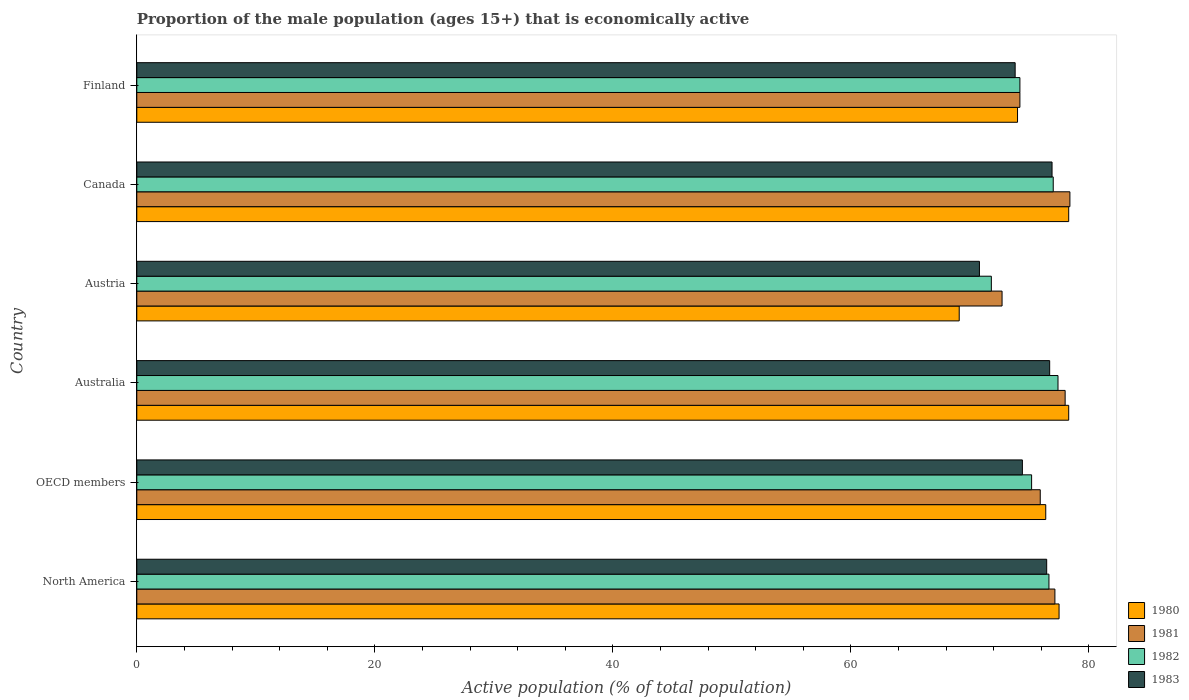How many different coloured bars are there?
Give a very brief answer. 4. How many groups of bars are there?
Provide a short and direct response. 6. Are the number of bars on each tick of the Y-axis equal?
Your response must be concise. Yes. How many bars are there on the 4th tick from the top?
Make the answer very short. 4. How many bars are there on the 5th tick from the bottom?
Your response must be concise. 4. What is the label of the 1st group of bars from the top?
Offer a terse response. Finland. What is the proportion of the male population that is economically active in 1982 in Finland?
Your answer should be compact. 74.2. Across all countries, what is the maximum proportion of the male population that is economically active in 1980?
Give a very brief answer. 78.3. Across all countries, what is the minimum proportion of the male population that is economically active in 1981?
Keep it short and to the point. 72.7. In which country was the proportion of the male population that is economically active in 1980 maximum?
Offer a very short reply. Australia. What is the total proportion of the male population that is economically active in 1983 in the graph?
Your answer should be very brief. 449.06. What is the difference between the proportion of the male population that is economically active in 1982 in Australia and that in Austria?
Provide a succinct answer. 5.6. What is the difference between the proportion of the male population that is economically active in 1980 in OECD members and the proportion of the male population that is economically active in 1982 in Canada?
Offer a terse response. -0.63. What is the average proportion of the male population that is economically active in 1980 per country?
Your response must be concise. 75.59. What is the difference between the proportion of the male population that is economically active in 1981 and proportion of the male population that is economically active in 1983 in Austria?
Keep it short and to the point. 1.9. In how many countries, is the proportion of the male population that is economically active in 1981 greater than 68 %?
Ensure brevity in your answer.  6. What is the ratio of the proportion of the male population that is economically active in 1983 in Canada to that in OECD members?
Make the answer very short. 1.03. Is the difference between the proportion of the male population that is economically active in 1981 in Austria and OECD members greater than the difference between the proportion of the male population that is economically active in 1983 in Austria and OECD members?
Give a very brief answer. Yes. What is the difference between the highest and the second highest proportion of the male population that is economically active in 1981?
Provide a short and direct response. 0.4. What is the difference between the highest and the lowest proportion of the male population that is economically active in 1980?
Ensure brevity in your answer.  9.2. In how many countries, is the proportion of the male population that is economically active in 1980 greater than the average proportion of the male population that is economically active in 1980 taken over all countries?
Make the answer very short. 4. Is the sum of the proportion of the male population that is economically active in 1981 in Canada and OECD members greater than the maximum proportion of the male population that is economically active in 1982 across all countries?
Provide a succinct answer. Yes. What does the 2nd bar from the bottom in Finland represents?
Keep it short and to the point. 1981. How many bars are there?
Your response must be concise. 24. How many countries are there in the graph?
Give a very brief answer. 6. Does the graph contain any zero values?
Offer a terse response. No. Does the graph contain grids?
Your response must be concise. No. How are the legend labels stacked?
Offer a very short reply. Vertical. What is the title of the graph?
Give a very brief answer. Proportion of the male population (ages 15+) that is economically active. What is the label or title of the X-axis?
Offer a very short reply. Active population (% of total population). What is the Active population (% of total population) in 1980 in North America?
Offer a terse response. 77.49. What is the Active population (% of total population) in 1981 in North America?
Your answer should be compact. 77.14. What is the Active population (% of total population) in 1982 in North America?
Your answer should be very brief. 76.64. What is the Active population (% of total population) in 1983 in North America?
Make the answer very short. 76.45. What is the Active population (% of total population) in 1980 in OECD members?
Your answer should be very brief. 76.37. What is the Active population (% of total population) in 1981 in OECD members?
Give a very brief answer. 75.91. What is the Active population (% of total population) in 1982 in OECD members?
Offer a very short reply. 75.18. What is the Active population (% of total population) in 1983 in OECD members?
Provide a short and direct response. 74.41. What is the Active population (% of total population) in 1980 in Australia?
Give a very brief answer. 78.3. What is the Active population (% of total population) of 1982 in Australia?
Your response must be concise. 77.4. What is the Active population (% of total population) of 1983 in Australia?
Keep it short and to the point. 76.7. What is the Active population (% of total population) in 1980 in Austria?
Offer a very short reply. 69.1. What is the Active population (% of total population) of 1981 in Austria?
Your answer should be very brief. 72.7. What is the Active population (% of total population) in 1982 in Austria?
Provide a short and direct response. 71.8. What is the Active population (% of total population) of 1983 in Austria?
Offer a very short reply. 70.8. What is the Active population (% of total population) in 1980 in Canada?
Give a very brief answer. 78.3. What is the Active population (% of total population) of 1981 in Canada?
Your response must be concise. 78.4. What is the Active population (% of total population) in 1982 in Canada?
Your answer should be compact. 77. What is the Active population (% of total population) in 1983 in Canada?
Provide a short and direct response. 76.9. What is the Active population (% of total population) in 1981 in Finland?
Your response must be concise. 74.2. What is the Active population (% of total population) in 1982 in Finland?
Your response must be concise. 74.2. What is the Active population (% of total population) in 1983 in Finland?
Make the answer very short. 73.8. Across all countries, what is the maximum Active population (% of total population) of 1980?
Offer a terse response. 78.3. Across all countries, what is the maximum Active population (% of total population) in 1981?
Your answer should be compact. 78.4. Across all countries, what is the maximum Active population (% of total population) of 1982?
Ensure brevity in your answer.  77.4. Across all countries, what is the maximum Active population (% of total population) in 1983?
Provide a succinct answer. 76.9. Across all countries, what is the minimum Active population (% of total population) in 1980?
Offer a very short reply. 69.1. Across all countries, what is the minimum Active population (% of total population) of 1981?
Offer a terse response. 72.7. Across all countries, what is the minimum Active population (% of total population) in 1982?
Keep it short and to the point. 71.8. Across all countries, what is the minimum Active population (% of total population) in 1983?
Ensure brevity in your answer.  70.8. What is the total Active population (% of total population) of 1980 in the graph?
Give a very brief answer. 453.56. What is the total Active population (% of total population) in 1981 in the graph?
Give a very brief answer. 456.35. What is the total Active population (% of total population) in 1982 in the graph?
Make the answer very short. 452.22. What is the total Active population (% of total population) in 1983 in the graph?
Your answer should be very brief. 449.06. What is the difference between the Active population (% of total population) of 1980 in North America and that in OECD members?
Provide a succinct answer. 1.12. What is the difference between the Active population (% of total population) of 1981 in North America and that in OECD members?
Provide a succinct answer. 1.23. What is the difference between the Active population (% of total population) in 1982 in North America and that in OECD members?
Keep it short and to the point. 1.46. What is the difference between the Active population (% of total population) of 1983 in North America and that in OECD members?
Offer a very short reply. 2.04. What is the difference between the Active population (% of total population) of 1980 in North America and that in Australia?
Provide a succinct answer. -0.81. What is the difference between the Active population (% of total population) of 1981 in North America and that in Australia?
Provide a short and direct response. -0.86. What is the difference between the Active population (% of total population) of 1982 in North America and that in Australia?
Make the answer very short. -0.76. What is the difference between the Active population (% of total population) of 1983 in North America and that in Australia?
Offer a very short reply. -0.25. What is the difference between the Active population (% of total population) of 1980 in North America and that in Austria?
Your answer should be very brief. 8.39. What is the difference between the Active population (% of total population) of 1981 in North America and that in Austria?
Keep it short and to the point. 4.44. What is the difference between the Active population (% of total population) of 1982 in North America and that in Austria?
Give a very brief answer. 4.84. What is the difference between the Active population (% of total population) of 1983 in North America and that in Austria?
Keep it short and to the point. 5.65. What is the difference between the Active population (% of total population) in 1980 in North America and that in Canada?
Your answer should be very brief. -0.81. What is the difference between the Active population (% of total population) of 1981 in North America and that in Canada?
Make the answer very short. -1.26. What is the difference between the Active population (% of total population) in 1982 in North America and that in Canada?
Your answer should be very brief. -0.36. What is the difference between the Active population (% of total population) of 1983 in North America and that in Canada?
Offer a terse response. -0.45. What is the difference between the Active population (% of total population) in 1980 in North America and that in Finland?
Ensure brevity in your answer.  3.49. What is the difference between the Active population (% of total population) of 1981 in North America and that in Finland?
Offer a terse response. 2.94. What is the difference between the Active population (% of total population) in 1982 in North America and that in Finland?
Keep it short and to the point. 2.44. What is the difference between the Active population (% of total population) in 1983 in North America and that in Finland?
Offer a terse response. 2.65. What is the difference between the Active population (% of total population) in 1980 in OECD members and that in Australia?
Give a very brief answer. -1.93. What is the difference between the Active population (% of total population) of 1981 in OECD members and that in Australia?
Give a very brief answer. -2.09. What is the difference between the Active population (% of total population) in 1982 in OECD members and that in Australia?
Your response must be concise. -2.22. What is the difference between the Active population (% of total population) in 1983 in OECD members and that in Australia?
Your answer should be very brief. -2.29. What is the difference between the Active population (% of total population) of 1980 in OECD members and that in Austria?
Your answer should be compact. 7.27. What is the difference between the Active population (% of total population) in 1981 in OECD members and that in Austria?
Offer a very short reply. 3.21. What is the difference between the Active population (% of total population) of 1982 in OECD members and that in Austria?
Your answer should be very brief. 3.38. What is the difference between the Active population (% of total population) in 1983 in OECD members and that in Austria?
Offer a very short reply. 3.61. What is the difference between the Active population (% of total population) in 1980 in OECD members and that in Canada?
Keep it short and to the point. -1.93. What is the difference between the Active population (% of total population) of 1981 in OECD members and that in Canada?
Keep it short and to the point. -2.49. What is the difference between the Active population (% of total population) of 1982 in OECD members and that in Canada?
Your answer should be very brief. -1.82. What is the difference between the Active population (% of total population) of 1983 in OECD members and that in Canada?
Your answer should be very brief. -2.49. What is the difference between the Active population (% of total population) in 1980 in OECD members and that in Finland?
Your response must be concise. 2.37. What is the difference between the Active population (% of total population) in 1981 in OECD members and that in Finland?
Your response must be concise. 1.71. What is the difference between the Active population (% of total population) in 1982 in OECD members and that in Finland?
Offer a very short reply. 0.98. What is the difference between the Active population (% of total population) in 1983 in OECD members and that in Finland?
Ensure brevity in your answer.  0.61. What is the difference between the Active population (% of total population) in 1982 in Australia and that in Austria?
Make the answer very short. 5.6. What is the difference between the Active population (% of total population) of 1983 in Australia and that in Austria?
Your answer should be compact. 5.9. What is the difference between the Active population (% of total population) in 1980 in Australia and that in Finland?
Offer a very short reply. 4.3. What is the difference between the Active population (% of total population) in 1982 in Australia and that in Finland?
Ensure brevity in your answer.  3.2. What is the difference between the Active population (% of total population) of 1981 in Austria and that in Canada?
Provide a short and direct response. -5.7. What is the difference between the Active population (% of total population) in 1981 in Austria and that in Finland?
Keep it short and to the point. -1.5. What is the difference between the Active population (% of total population) in 1982 in Austria and that in Finland?
Your response must be concise. -2.4. What is the difference between the Active population (% of total population) of 1983 in Austria and that in Finland?
Your response must be concise. -3. What is the difference between the Active population (% of total population) in 1980 in North America and the Active population (% of total population) in 1981 in OECD members?
Your answer should be compact. 1.58. What is the difference between the Active population (% of total population) of 1980 in North America and the Active population (% of total population) of 1982 in OECD members?
Your answer should be compact. 2.31. What is the difference between the Active population (% of total population) of 1980 in North America and the Active population (% of total population) of 1983 in OECD members?
Your response must be concise. 3.08. What is the difference between the Active population (% of total population) in 1981 in North America and the Active population (% of total population) in 1982 in OECD members?
Offer a very short reply. 1.96. What is the difference between the Active population (% of total population) in 1981 in North America and the Active population (% of total population) in 1983 in OECD members?
Offer a very short reply. 2.73. What is the difference between the Active population (% of total population) of 1982 in North America and the Active population (% of total population) of 1983 in OECD members?
Your response must be concise. 2.23. What is the difference between the Active population (% of total population) of 1980 in North America and the Active population (% of total population) of 1981 in Australia?
Provide a short and direct response. -0.51. What is the difference between the Active population (% of total population) of 1980 in North America and the Active population (% of total population) of 1982 in Australia?
Ensure brevity in your answer.  0.09. What is the difference between the Active population (% of total population) in 1980 in North America and the Active population (% of total population) in 1983 in Australia?
Your answer should be very brief. 0.79. What is the difference between the Active population (% of total population) of 1981 in North America and the Active population (% of total population) of 1982 in Australia?
Offer a very short reply. -0.26. What is the difference between the Active population (% of total population) of 1981 in North America and the Active population (% of total population) of 1983 in Australia?
Offer a terse response. 0.44. What is the difference between the Active population (% of total population) of 1982 in North America and the Active population (% of total population) of 1983 in Australia?
Ensure brevity in your answer.  -0.06. What is the difference between the Active population (% of total population) in 1980 in North America and the Active population (% of total population) in 1981 in Austria?
Offer a very short reply. 4.79. What is the difference between the Active population (% of total population) of 1980 in North America and the Active population (% of total population) of 1982 in Austria?
Provide a short and direct response. 5.69. What is the difference between the Active population (% of total population) of 1980 in North America and the Active population (% of total population) of 1983 in Austria?
Give a very brief answer. 6.69. What is the difference between the Active population (% of total population) in 1981 in North America and the Active population (% of total population) in 1982 in Austria?
Provide a short and direct response. 5.34. What is the difference between the Active population (% of total population) of 1981 in North America and the Active population (% of total population) of 1983 in Austria?
Give a very brief answer. 6.34. What is the difference between the Active population (% of total population) of 1982 in North America and the Active population (% of total population) of 1983 in Austria?
Offer a very short reply. 5.84. What is the difference between the Active population (% of total population) of 1980 in North America and the Active population (% of total population) of 1981 in Canada?
Give a very brief answer. -0.91. What is the difference between the Active population (% of total population) in 1980 in North America and the Active population (% of total population) in 1982 in Canada?
Your answer should be compact. 0.49. What is the difference between the Active population (% of total population) of 1980 in North America and the Active population (% of total population) of 1983 in Canada?
Ensure brevity in your answer.  0.59. What is the difference between the Active population (% of total population) of 1981 in North America and the Active population (% of total population) of 1982 in Canada?
Your response must be concise. 0.14. What is the difference between the Active population (% of total population) in 1981 in North America and the Active population (% of total population) in 1983 in Canada?
Give a very brief answer. 0.24. What is the difference between the Active population (% of total population) in 1982 in North America and the Active population (% of total population) in 1983 in Canada?
Offer a terse response. -0.26. What is the difference between the Active population (% of total population) in 1980 in North America and the Active population (% of total population) in 1981 in Finland?
Offer a very short reply. 3.29. What is the difference between the Active population (% of total population) in 1980 in North America and the Active population (% of total population) in 1982 in Finland?
Your answer should be very brief. 3.29. What is the difference between the Active population (% of total population) of 1980 in North America and the Active population (% of total population) of 1983 in Finland?
Provide a short and direct response. 3.69. What is the difference between the Active population (% of total population) in 1981 in North America and the Active population (% of total population) in 1982 in Finland?
Your answer should be very brief. 2.94. What is the difference between the Active population (% of total population) of 1981 in North America and the Active population (% of total population) of 1983 in Finland?
Make the answer very short. 3.34. What is the difference between the Active population (% of total population) in 1982 in North America and the Active population (% of total population) in 1983 in Finland?
Your response must be concise. 2.84. What is the difference between the Active population (% of total population) in 1980 in OECD members and the Active population (% of total population) in 1981 in Australia?
Your response must be concise. -1.63. What is the difference between the Active population (% of total population) of 1980 in OECD members and the Active population (% of total population) of 1982 in Australia?
Your answer should be compact. -1.03. What is the difference between the Active population (% of total population) of 1980 in OECD members and the Active population (% of total population) of 1983 in Australia?
Ensure brevity in your answer.  -0.33. What is the difference between the Active population (% of total population) of 1981 in OECD members and the Active population (% of total population) of 1982 in Australia?
Provide a succinct answer. -1.49. What is the difference between the Active population (% of total population) of 1981 in OECD members and the Active population (% of total population) of 1983 in Australia?
Your answer should be compact. -0.79. What is the difference between the Active population (% of total population) of 1982 in OECD members and the Active population (% of total population) of 1983 in Australia?
Your answer should be very brief. -1.52. What is the difference between the Active population (% of total population) of 1980 in OECD members and the Active population (% of total population) of 1981 in Austria?
Ensure brevity in your answer.  3.67. What is the difference between the Active population (% of total population) of 1980 in OECD members and the Active population (% of total population) of 1982 in Austria?
Keep it short and to the point. 4.57. What is the difference between the Active population (% of total population) in 1980 in OECD members and the Active population (% of total population) in 1983 in Austria?
Offer a very short reply. 5.57. What is the difference between the Active population (% of total population) of 1981 in OECD members and the Active population (% of total population) of 1982 in Austria?
Ensure brevity in your answer.  4.11. What is the difference between the Active population (% of total population) in 1981 in OECD members and the Active population (% of total population) in 1983 in Austria?
Your response must be concise. 5.11. What is the difference between the Active population (% of total population) of 1982 in OECD members and the Active population (% of total population) of 1983 in Austria?
Your answer should be very brief. 4.38. What is the difference between the Active population (% of total population) in 1980 in OECD members and the Active population (% of total population) in 1981 in Canada?
Provide a short and direct response. -2.03. What is the difference between the Active population (% of total population) in 1980 in OECD members and the Active population (% of total population) in 1982 in Canada?
Your answer should be compact. -0.63. What is the difference between the Active population (% of total population) in 1980 in OECD members and the Active population (% of total population) in 1983 in Canada?
Give a very brief answer. -0.53. What is the difference between the Active population (% of total population) of 1981 in OECD members and the Active population (% of total population) of 1982 in Canada?
Provide a short and direct response. -1.09. What is the difference between the Active population (% of total population) in 1981 in OECD members and the Active population (% of total population) in 1983 in Canada?
Your response must be concise. -0.99. What is the difference between the Active population (% of total population) in 1982 in OECD members and the Active population (% of total population) in 1983 in Canada?
Provide a short and direct response. -1.72. What is the difference between the Active population (% of total population) of 1980 in OECD members and the Active population (% of total population) of 1981 in Finland?
Ensure brevity in your answer.  2.17. What is the difference between the Active population (% of total population) of 1980 in OECD members and the Active population (% of total population) of 1982 in Finland?
Your answer should be compact. 2.17. What is the difference between the Active population (% of total population) in 1980 in OECD members and the Active population (% of total population) in 1983 in Finland?
Your answer should be compact. 2.57. What is the difference between the Active population (% of total population) of 1981 in OECD members and the Active population (% of total population) of 1982 in Finland?
Ensure brevity in your answer.  1.71. What is the difference between the Active population (% of total population) of 1981 in OECD members and the Active population (% of total population) of 1983 in Finland?
Your response must be concise. 2.11. What is the difference between the Active population (% of total population) of 1982 in OECD members and the Active population (% of total population) of 1983 in Finland?
Your answer should be very brief. 1.38. What is the difference between the Active population (% of total population) in 1980 in Australia and the Active population (% of total population) in 1981 in Austria?
Your answer should be very brief. 5.6. What is the difference between the Active population (% of total population) of 1980 in Australia and the Active population (% of total population) of 1983 in Austria?
Provide a succinct answer. 7.5. What is the difference between the Active population (% of total population) of 1981 in Australia and the Active population (% of total population) of 1982 in Austria?
Your answer should be very brief. 6.2. What is the difference between the Active population (% of total population) in 1981 in Australia and the Active population (% of total population) in 1983 in Austria?
Offer a very short reply. 7.2. What is the difference between the Active population (% of total population) of 1982 in Australia and the Active population (% of total population) of 1983 in Austria?
Your answer should be very brief. 6.6. What is the difference between the Active population (% of total population) in 1980 in Australia and the Active population (% of total population) in 1982 in Canada?
Keep it short and to the point. 1.3. What is the difference between the Active population (% of total population) of 1981 in Australia and the Active population (% of total population) of 1982 in Canada?
Offer a terse response. 1. What is the difference between the Active population (% of total population) of 1980 in Australia and the Active population (% of total population) of 1982 in Finland?
Give a very brief answer. 4.1. What is the difference between the Active population (% of total population) in 1980 in Australia and the Active population (% of total population) in 1983 in Finland?
Make the answer very short. 4.5. What is the difference between the Active population (% of total population) in 1981 in Australia and the Active population (% of total population) in 1982 in Finland?
Provide a short and direct response. 3.8. What is the difference between the Active population (% of total population) of 1981 in Australia and the Active population (% of total population) of 1983 in Finland?
Provide a short and direct response. 4.2. What is the difference between the Active population (% of total population) in 1982 in Australia and the Active population (% of total population) in 1983 in Finland?
Give a very brief answer. 3.6. What is the difference between the Active population (% of total population) in 1980 in Austria and the Active population (% of total population) in 1983 in Canada?
Make the answer very short. -7.8. What is the difference between the Active population (% of total population) of 1981 in Austria and the Active population (% of total population) of 1983 in Canada?
Your response must be concise. -4.2. What is the difference between the Active population (% of total population) in 1980 in Austria and the Active population (% of total population) in 1981 in Finland?
Provide a succinct answer. -5.1. What is the difference between the Active population (% of total population) of 1980 in Austria and the Active population (% of total population) of 1982 in Finland?
Give a very brief answer. -5.1. What is the difference between the Active population (% of total population) in 1981 in Austria and the Active population (% of total population) in 1982 in Finland?
Offer a terse response. -1.5. What is the difference between the Active population (% of total population) in 1982 in Austria and the Active population (% of total population) in 1983 in Finland?
Ensure brevity in your answer.  -2. What is the difference between the Active population (% of total population) of 1980 in Canada and the Active population (% of total population) of 1982 in Finland?
Provide a succinct answer. 4.1. What is the difference between the Active population (% of total population) in 1981 in Canada and the Active population (% of total population) in 1982 in Finland?
Give a very brief answer. 4.2. What is the average Active population (% of total population) of 1980 per country?
Provide a short and direct response. 75.59. What is the average Active population (% of total population) of 1981 per country?
Your answer should be compact. 76.06. What is the average Active population (% of total population) in 1982 per country?
Provide a short and direct response. 75.37. What is the average Active population (% of total population) of 1983 per country?
Give a very brief answer. 74.84. What is the difference between the Active population (% of total population) of 1980 and Active population (% of total population) of 1981 in North America?
Your response must be concise. 0.35. What is the difference between the Active population (% of total population) in 1980 and Active population (% of total population) in 1982 in North America?
Your response must be concise. 0.85. What is the difference between the Active population (% of total population) of 1980 and Active population (% of total population) of 1983 in North America?
Provide a succinct answer. 1.04. What is the difference between the Active population (% of total population) of 1981 and Active population (% of total population) of 1982 in North America?
Offer a terse response. 0.5. What is the difference between the Active population (% of total population) of 1981 and Active population (% of total population) of 1983 in North America?
Make the answer very short. 0.69. What is the difference between the Active population (% of total population) in 1982 and Active population (% of total population) in 1983 in North America?
Your response must be concise. 0.19. What is the difference between the Active population (% of total population) in 1980 and Active population (% of total population) in 1981 in OECD members?
Your answer should be compact. 0.46. What is the difference between the Active population (% of total population) of 1980 and Active population (% of total population) of 1982 in OECD members?
Keep it short and to the point. 1.19. What is the difference between the Active population (% of total population) in 1980 and Active population (% of total population) in 1983 in OECD members?
Provide a succinct answer. 1.96. What is the difference between the Active population (% of total population) in 1981 and Active population (% of total population) in 1982 in OECD members?
Make the answer very short. 0.73. What is the difference between the Active population (% of total population) in 1981 and Active population (% of total population) in 1983 in OECD members?
Your answer should be very brief. 1.5. What is the difference between the Active population (% of total population) in 1982 and Active population (% of total population) in 1983 in OECD members?
Offer a terse response. 0.77. What is the difference between the Active population (% of total population) of 1980 and Active population (% of total population) of 1982 in Australia?
Your answer should be compact. 0.9. What is the difference between the Active population (% of total population) in 1980 and Active population (% of total population) in 1983 in Australia?
Keep it short and to the point. 1.6. What is the difference between the Active population (% of total population) of 1981 and Active population (% of total population) of 1982 in Australia?
Your answer should be very brief. 0.6. What is the difference between the Active population (% of total population) of 1982 and Active population (% of total population) of 1983 in Australia?
Make the answer very short. 0.7. What is the difference between the Active population (% of total population) of 1980 and Active population (% of total population) of 1982 in Austria?
Keep it short and to the point. -2.7. What is the difference between the Active population (% of total population) of 1980 and Active population (% of total population) of 1983 in Austria?
Make the answer very short. -1.7. What is the difference between the Active population (% of total population) of 1981 and Active population (% of total population) of 1982 in Austria?
Your response must be concise. 0.9. What is the difference between the Active population (% of total population) in 1981 and Active population (% of total population) in 1983 in Austria?
Your answer should be very brief. 1.9. What is the difference between the Active population (% of total population) in 1980 and Active population (% of total population) in 1983 in Canada?
Provide a short and direct response. 1.4. What is the difference between the Active population (% of total population) in 1982 and Active population (% of total population) in 1983 in Canada?
Offer a terse response. 0.1. What is the difference between the Active population (% of total population) of 1980 and Active population (% of total population) of 1981 in Finland?
Keep it short and to the point. -0.2. What is the difference between the Active population (% of total population) in 1980 and Active population (% of total population) in 1983 in Finland?
Provide a succinct answer. 0.2. What is the ratio of the Active population (% of total population) of 1980 in North America to that in OECD members?
Give a very brief answer. 1.01. What is the ratio of the Active population (% of total population) of 1981 in North America to that in OECD members?
Keep it short and to the point. 1.02. What is the ratio of the Active population (% of total population) in 1982 in North America to that in OECD members?
Provide a succinct answer. 1.02. What is the ratio of the Active population (% of total population) of 1983 in North America to that in OECD members?
Keep it short and to the point. 1.03. What is the ratio of the Active population (% of total population) of 1980 in North America to that in Australia?
Offer a terse response. 0.99. What is the ratio of the Active population (% of total population) in 1981 in North America to that in Australia?
Provide a succinct answer. 0.99. What is the ratio of the Active population (% of total population) of 1982 in North America to that in Australia?
Offer a very short reply. 0.99. What is the ratio of the Active population (% of total population) in 1980 in North America to that in Austria?
Make the answer very short. 1.12. What is the ratio of the Active population (% of total population) in 1981 in North America to that in Austria?
Your response must be concise. 1.06. What is the ratio of the Active population (% of total population) in 1982 in North America to that in Austria?
Keep it short and to the point. 1.07. What is the ratio of the Active population (% of total population) in 1983 in North America to that in Austria?
Provide a short and direct response. 1.08. What is the ratio of the Active population (% of total population) of 1981 in North America to that in Canada?
Offer a very short reply. 0.98. What is the ratio of the Active population (% of total population) in 1983 in North America to that in Canada?
Your answer should be very brief. 0.99. What is the ratio of the Active population (% of total population) in 1980 in North America to that in Finland?
Ensure brevity in your answer.  1.05. What is the ratio of the Active population (% of total population) in 1981 in North America to that in Finland?
Offer a terse response. 1.04. What is the ratio of the Active population (% of total population) in 1982 in North America to that in Finland?
Your answer should be very brief. 1.03. What is the ratio of the Active population (% of total population) in 1983 in North America to that in Finland?
Make the answer very short. 1.04. What is the ratio of the Active population (% of total population) of 1980 in OECD members to that in Australia?
Provide a succinct answer. 0.98. What is the ratio of the Active population (% of total population) in 1981 in OECD members to that in Australia?
Your answer should be compact. 0.97. What is the ratio of the Active population (% of total population) of 1982 in OECD members to that in Australia?
Make the answer very short. 0.97. What is the ratio of the Active population (% of total population) of 1983 in OECD members to that in Australia?
Provide a short and direct response. 0.97. What is the ratio of the Active population (% of total population) of 1980 in OECD members to that in Austria?
Give a very brief answer. 1.11. What is the ratio of the Active population (% of total population) of 1981 in OECD members to that in Austria?
Offer a very short reply. 1.04. What is the ratio of the Active population (% of total population) in 1982 in OECD members to that in Austria?
Offer a very short reply. 1.05. What is the ratio of the Active population (% of total population) in 1983 in OECD members to that in Austria?
Give a very brief answer. 1.05. What is the ratio of the Active population (% of total population) of 1980 in OECD members to that in Canada?
Make the answer very short. 0.98. What is the ratio of the Active population (% of total population) in 1981 in OECD members to that in Canada?
Ensure brevity in your answer.  0.97. What is the ratio of the Active population (% of total population) in 1982 in OECD members to that in Canada?
Provide a succinct answer. 0.98. What is the ratio of the Active population (% of total population) in 1983 in OECD members to that in Canada?
Your response must be concise. 0.97. What is the ratio of the Active population (% of total population) in 1980 in OECD members to that in Finland?
Your answer should be very brief. 1.03. What is the ratio of the Active population (% of total population) of 1982 in OECD members to that in Finland?
Provide a succinct answer. 1.01. What is the ratio of the Active population (% of total population) in 1983 in OECD members to that in Finland?
Make the answer very short. 1.01. What is the ratio of the Active population (% of total population) of 1980 in Australia to that in Austria?
Offer a terse response. 1.13. What is the ratio of the Active population (% of total population) of 1981 in Australia to that in Austria?
Your answer should be very brief. 1.07. What is the ratio of the Active population (% of total population) of 1982 in Australia to that in Austria?
Ensure brevity in your answer.  1.08. What is the ratio of the Active population (% of total population) in 1983 in Australia to that in Austria?
Your answer should be very brief. 1.08. What is the ratio of the Active population (% of total population) in 1981 in Australia to that in Canada?
Provide a short and direct response. 0.99. What is the ratio of the Active population (% of total population) in 1982 in Australia to that in Canada?
Keep it short and to the point. 1.01. What is the ratio of the Active population (% of total population) in 1980 in Australia to that in Finland?
Provide a short and direct response. 1.06. What is the ratio of the Active population (% of total population) in 1981 in Australia to that in Finland?
Give a very brief answer. 1.05. What is the ratio of the Active population (% of total population) in 1982 in Australia to that in Finland?
Make the answer very short. 1.04. What is the ratio of the Active population (% of total population) of 1983 in Australia to that in Finland?
Offer a terse response. 1.04. What is the ratio of the Active population (% of total population) in 1980 in Austria to that in Canada?
Offer a terse response. 0.88. What is the ratio of the Active population (% of total population) of 1981 in Austria to that in Canada?
Make the answer very short. 0.93. What is the ratio of the Active population (% of total population) in 1982 in Austria to that in Canada?
Ensure brevity in your answer.  0.93. What is the ratio of the Active population (% of total population) in 1983 in Austria to that in Canada?
Ensure brevity in your answer.  0.92. What is the ratio of the Active population (% of total population) in 1980 in Austria to that in Finland?
Provide a succinct answer. 0.93. What is the ratio of the Active population (% of total population) of 1981 in Austria to that in Finland?
Your answer should be very brief. 0.98. What is the ratio of the Active population (% of total population) of 1982 in Austria to that in Finland?
Your response must be concise. 0.97. What is the ratio of the Active population (% of total population) of 1983 in Austria to that in Finland?
Give a very brief answer. 0.96. What is the ratio of the Active population (% of total population) in 1980 in Canada to that in Finland?
Keep it short and to the point. 1.06. What is the ratio of the Active population (% of total population) of 1981 in Canada to that in Finland?
Your response must be concise. 1.06. What is the ratio of the Active population (% of total population) in 1982 in Canada to that in Finland?
Ensure brevity in your answer.  1.04. What is the ratio of the Active population (% of total population) in 1983 in Canada to that in Finland?
Give a very brief answer. 1.04. What is the difference between the highest and the second highest Active population (% of total population) in 1982?
Provide a succinct answer. 0.4. What is the difference between the highest and the lowest Active population (% of total population) in 1980?
Keep it short and to the point. 9.2. What is the difference between the highest and the lowest Active population (% of total population) of 1981?
Make the answer very short. 5.7. What is the difference between the highest and the lowest Active population (% of total population) of 1982?
Your response must be concise. 5.6. 